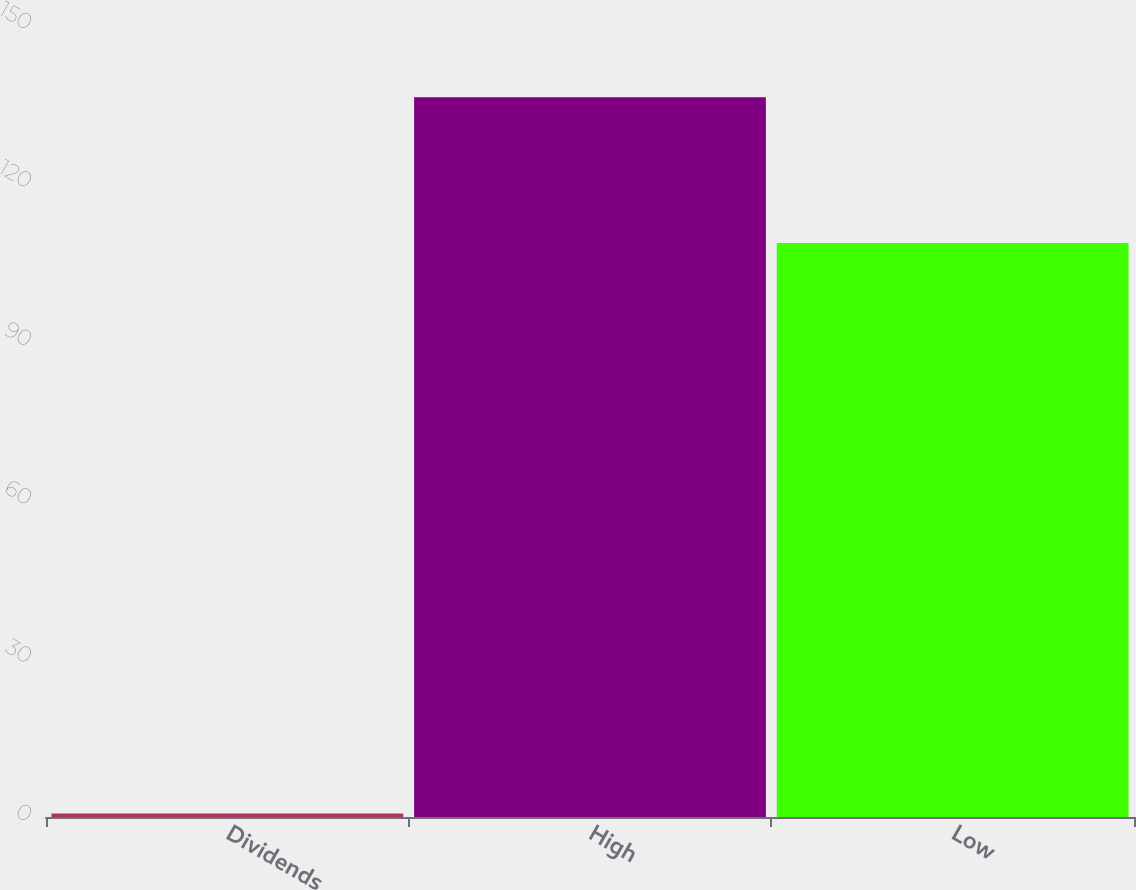Convert chart. <chart><loc_0><loc_0><loc_500><loc_500><bar_chart><fcel>Dividends<fcel>High<fcel>Low<nl><fcel>0.67<fcel>136.32<fcel>108.71<nl></chart> 